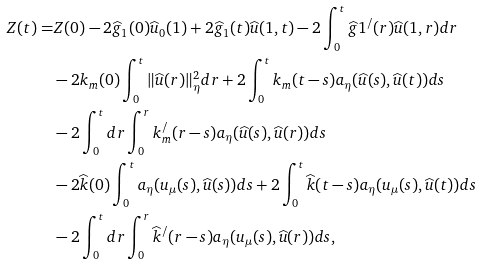<formula> <loc_0><loc_0><loc_500><loc_500>Z ( t ) = & Z ( 0 ) - 2 \widehat { g } _ { 1 } ( 0 ) \widehat { u } _ { 0 } ( 1 ) + 2 \widehat { g } _ { 1 } ( t ) \widehat { u } ( 1 , t ) - 2 \int _ { 0 } ^ { t } \widehat { g } 1 ^ { / } ( r ) \widehat { u } ( 1 , r ) d r \\ & - 2 k _ { m } ( 0 ) \int _ { 0 } ^ { t } \| \widehat { u } ( r ) \| _ { \eta } ^ { 2 } d r + 2 \int _ { 0 } ^ { t } k _ { m } ( t - s ) a _ { \eta } ( \widehat { u } ( s ) , \widehat { u } ( t ) ) d s \\ & - 2 \int _ { 0 } ^ { t } d r \int _ { 0 } ^ { r } k _ { m } ^ { / } ( r - s ) a _ { \eta } ( \widehat { u } ( s ) , \widehat { u } ( r ) ) d s \\ & - 2 \widehat { k } ( 0 ) \int _ { 0 } ^ { t } a _ { \eta } ( u _ { \mu } ( s ) , \widehat { u } ( s ) ) d s + 2 \int _ { 0 } ^ { t } \widehat { k } ( t - s ) a _ { \eta } ( u _ { \mu } ( s ) , \widehat { u } ( t ) ) d s \\ & - 2 \int _ { 0 } ^ { t } d r \int _ { 0 } ^ { r } \widehat { k } ^ { / } ( r - s ) a _ { \eta } ( u _ { \mu } ( s ) , \widehat { u } ( r ) ) d s ,</formula> 